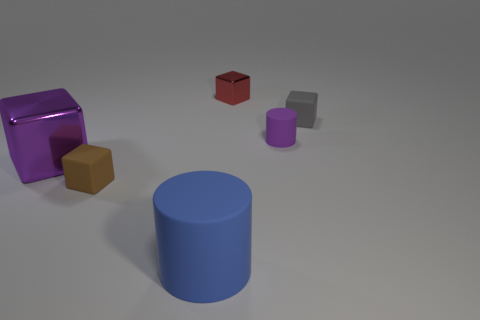What color is the rubber cylinder in front of the matte cylinder that is behind the big purple block?
Keep it short and to the point. Blue. What is the color of the thing that is the same size as the blue rubber cylinder?
Provide a succinct answer. Purple. Are there any big rubber cylinders of the same color as the tiny shiny object?
Provide a short and direct response. No. Is there a brown thing?
Your response must be concise. Yes. What is the shape of the brown object that is left of the purple cylinder?
Your answer should be very brief. Cube. What number of objects are both behind the tiny gray object and in front of the tiny gray thing?
Your response must be concise. 0. What number of other things are the same size as the blue rubber cylinder?
Your answer should be compact. 1. Does the big object in front of the big block have the same shape as the metallic thing that is behind the small cylinder?
Offer a very short reply. No. What number of things are either tiny brown matte cubes or objects that are right of the big rubber thing?
Offer a terse response. 4. What is the cube that is both behind the small brown object and left of the red shiny cube made of?
Keep it short and to the point. Metal. 